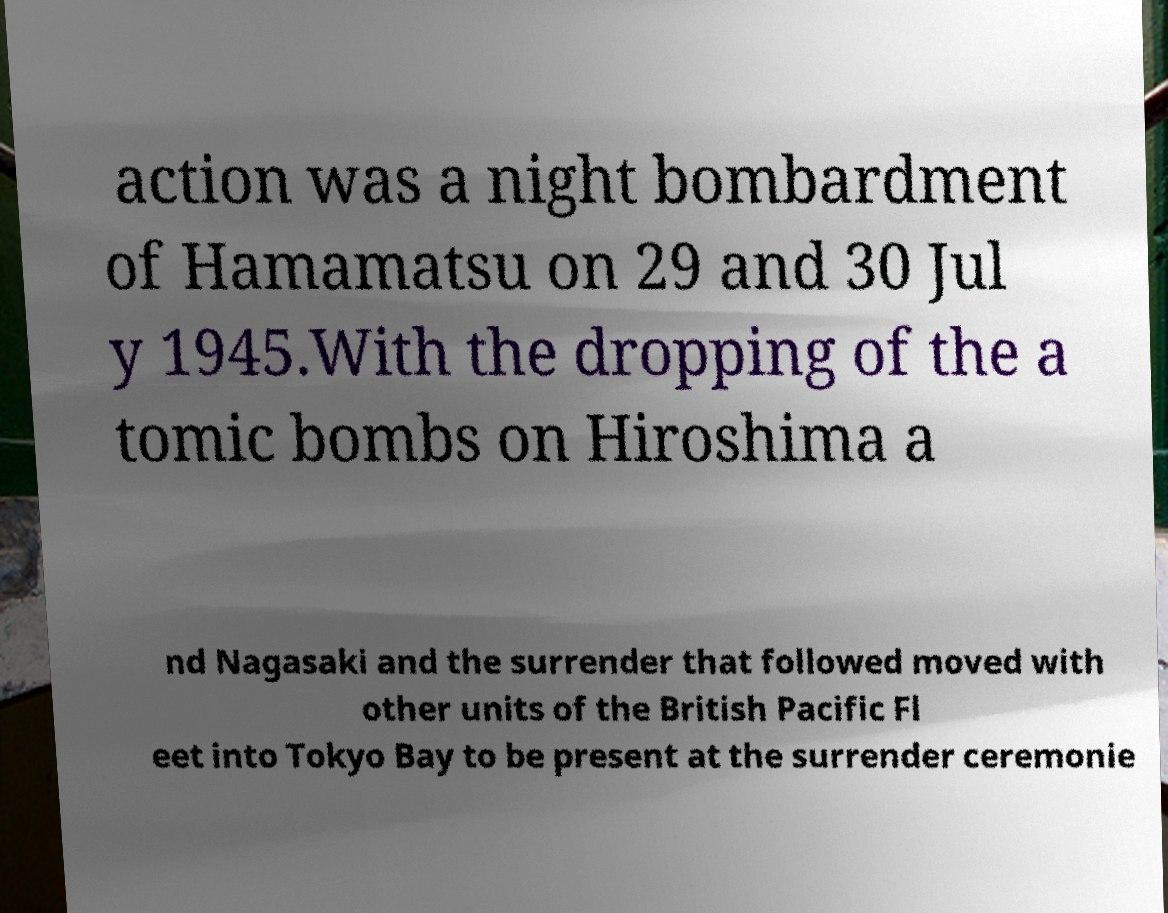Can you accurately transcribe the text from the provided image for me? action was a night bombardment of Hamamatsu on 29 and 30 Jul y 1945.With the dropping of the a tomic bombs on Hiroshima a nd Nagasaki and the surrender that followed moved with other units of the British Pacific Fl eet into Tokyo Bay to be present at the surrender ceremonie 